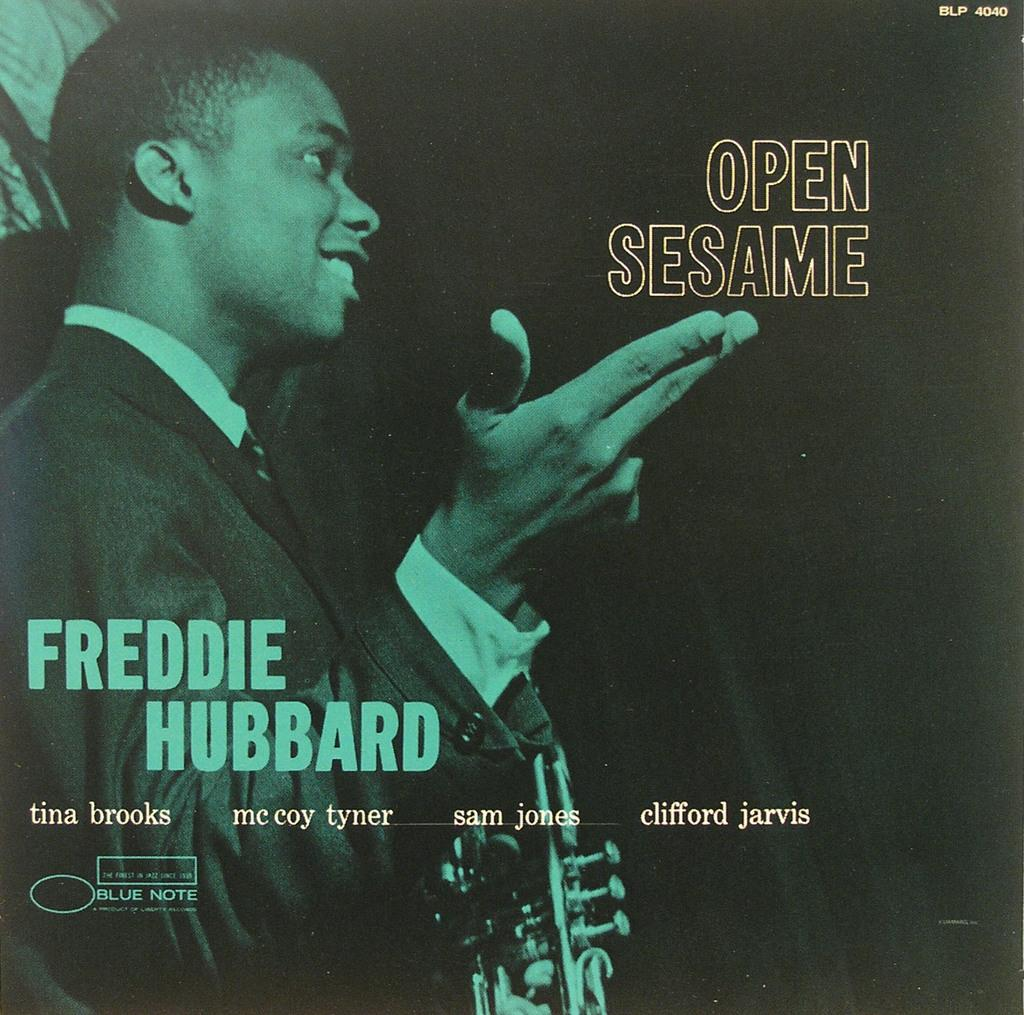<image>
Summarize the visual content of the image. A cover of Open Sesame by Freddie Hubbard. 